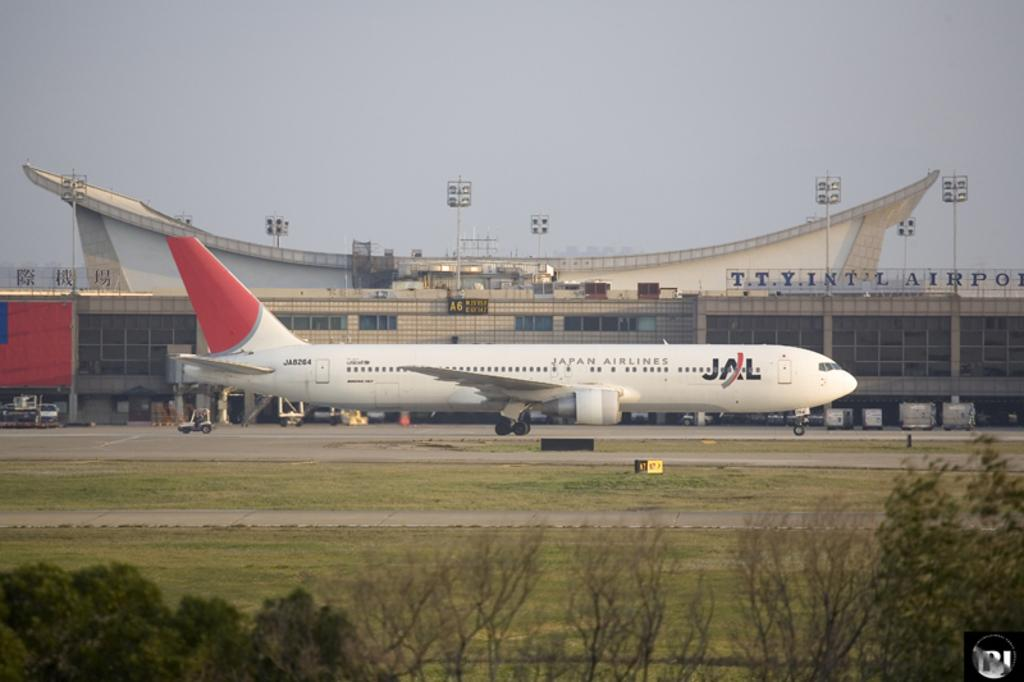<image>
Write a terse but informative summary of the picture. The white aircraft has a red tail and the letters JAL indicating it belongs to Japan Airlines. 